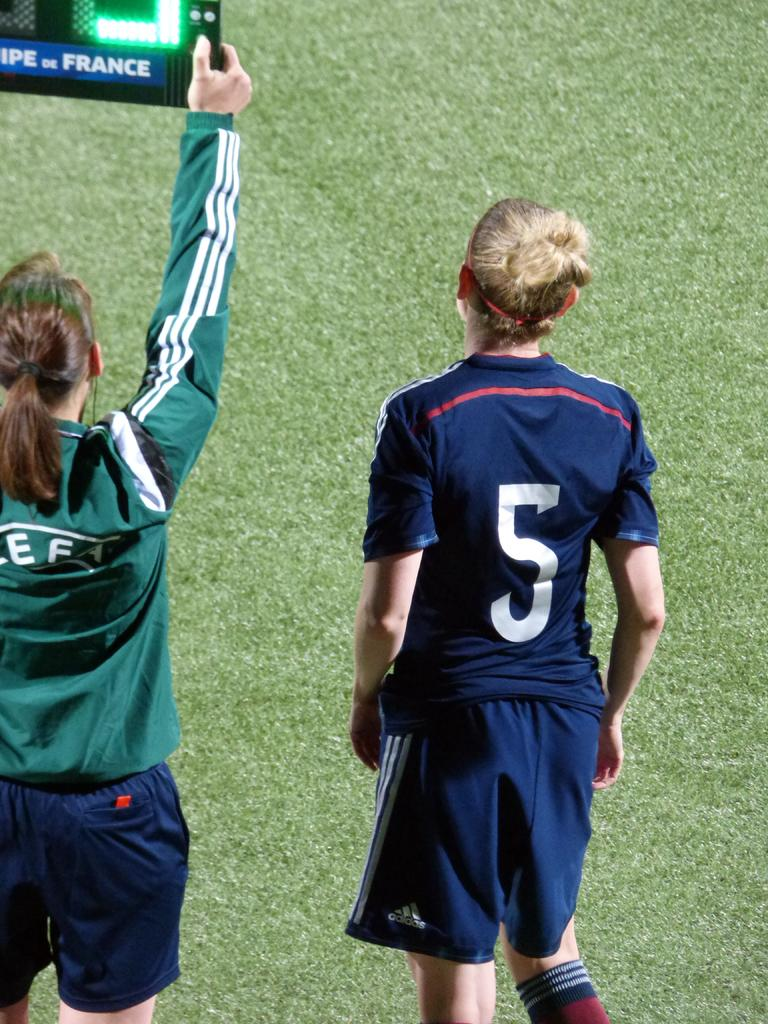<image>
Describe the image concisely. a player that has the number 5 on their jersey 